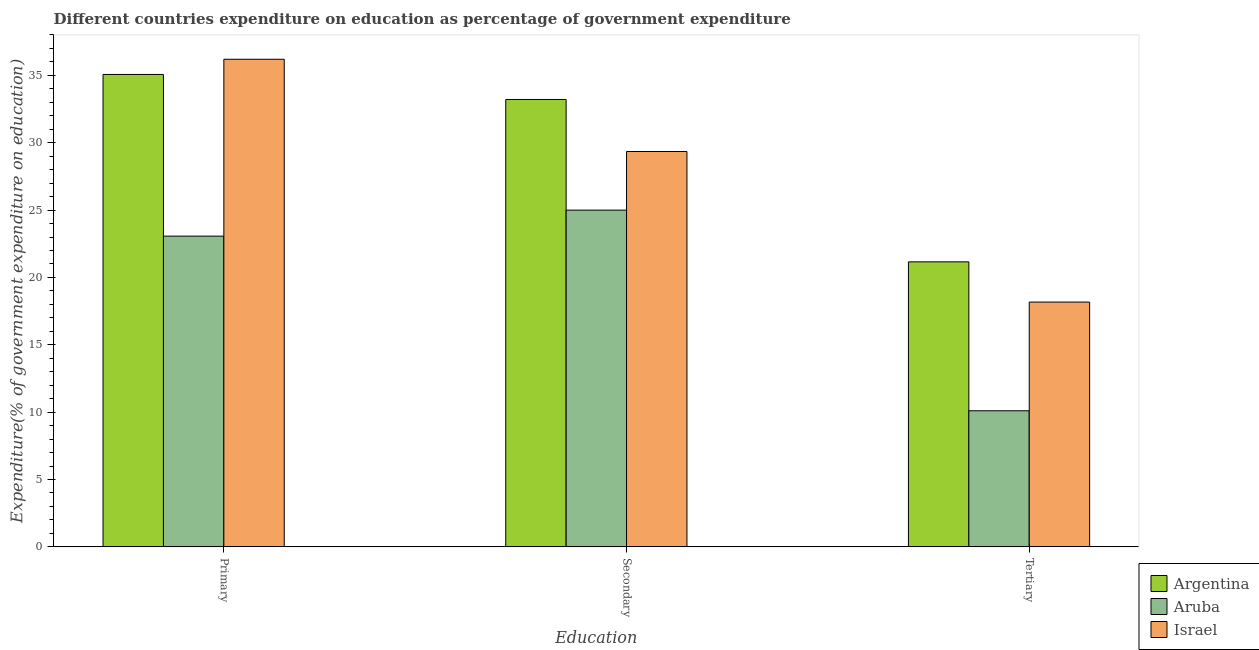How many different coloured bars are there?
Provide a short and direct response. 3. How many bars are there on the 2nd tick from the left?
Your response must be concise. 3. What is the label of the 3rd group of bars from the left?
Your answer should be very brief. Tertiary. What is the expenditure on secondary education in Aruba?
Your response must be concise. 25. Across all countries, what is the maximum expenditure on secondary education?
Your answer should be very brief. 33.21. Across all countries, what is the minimum expenditure on secondary education?
Offer a very short reply. 25. In which country was the expenditure on primary education minimum?
Ensure brevity in your answer.  Aruba. What is the total expenditure on primary education in the graph?
Offer a very short reply. 94.34. What is the difference between the expenditure on primary education in Aruba and that in Argentina?
Ensure brevity in your answer.  -12. What is the difference between the expenditure on tertiary education in Argentina and the expenditure on secondary education in Aruba?
Keep it short and to the point. -3.84. What is the average expenditure on tertiary education per country?
Provide a short and direct response. 16.48. What is the difference between the expenditure on secondary education and expenditure on tertiary education in Israel?
Your answer should be compact. 11.18. What is the ratio of the expenditure on primary education in Argentina to that in Aruba?
Provide a succinct answer. 1.52. What is the difference between the highest and the second highest expenditure on tertiary education?
Keep it short and to the point. 2.99. What is the difference between the highest and the lowest expenditure on tertiary education?
Provide a succinct answer. 11.06. Is the sum of the expenditure on secondary education in Argentina and Israel greater than the maximum expenditure on primary education across all countries?
Your answer should be very brief. Yes. What does the 2nd bar from the left in Primary represents?
Offer a very short reply. Aruba. What does the 3rd bar from the right in Secondary represents?
Your answer should be compact. Argentina. Is it the case that in every country, the sum of the expenditure on primary education and expenditure on secondary education is greater than the expenditure on tertiary education?
Your answer should be compact. Yes. Are the values on the major ticks of Y-axis written in scientific E-notation?
Give a very brief answer. No. Does the graph contain any zero values?
Offer a terse response. No. Where does the legend appear in the graph?
Your answer should be very brief. Bottom right. How are the legend labels stacked?
Offer a very short reply. Vertical. What is the title of the graph?
Provide a short and direct response. Different countries expenditure on education as percentage of government expenditure. What is the label or title of the X-axis?
Provide a short and direct response. Education. What is the label or title of the Y-axis?
Keep it short and to the point. Expenditure(% of government expenditure on education). What is the Expenditure(% of government expenditure on education) in Argentina in Primary?
Give a very brief answer. 35.07. What is the Expenditure(% of government expenditure on education) in Aruba in Primary?
Provide a succinct answer. 23.07. What is the Expenditure(% of government expenditure on education) in Israel in Primary?
Ensure brevity in your answer.  36.2. What is the Expenditure(% of government expenditure on education) in Argentina in Secondary?
Keep it short and to the point. 33.21. What is the Expenditure(% of government expenditure on education) of Aruba in Secondary?
Offer a terse response. 25. What is the Expenditure(% of government expenditure on education) of Israel in Secondary?
Provide a succinct answer. 29.35. What is the Expenditure(% of government expenditure on education) of Argentina in Tertiary?
Offer a terse response. 21.16. What is the Expenditure(% of government expenditure on education) in Aruba in Tertiary?
Your answer should be very brief. 10.1. What is the Expenditure(% of government expenditure on education) in Israel in Tertiary?
Your answer should be compact. 18.17. Across all Education, what is the maximum Expenditure(% of government expenditure on education) of Argentina?
Your answer should be very brief. 35.07. Across all Education, what is the maximum Expenditure(% of government expenditure on education) in Aruba?
Your answer should be compact. 25. Across all Education, what is the maximum Expenditure(% of government expenditure on education) in Israel?
Your answer should be compact. 36.2. Across all Education, what is the minimum Expenditure(% of government expenditure on education) in Argentina?
Ensure brevity in your answer.  21.16. Across all Education, what is the minimum Expenditure(% of government expenditure on education) in Aruba?
Offer a very short reply. 10.1. Across all Education, what is the minimum Expenditure(% of government expenditure on education) of Israel?
Your answer should be compact. 18.17. What is the total Expenditure(% of government expenditure on education) in Argentina in the graph?
Keep it short and to the point. 89.44. What is the total Expenditure(% of government expenditure on education) in Aruba in the graph?
Provide a succinct answer. 58.17. What is the total Expenditure(% of government expenditure on education) in Israel in the graph?
Offer a very short reply. 83.72. What is the difference between the Expenditure(% of government expenditure on education) of Argentina in Primary and that in Secondary?
Offer a very short reply. 1.86. What is the difference between the Expenditure(% of government expenditure on education) in Aruba in Primary and that in Secondary?
Provide a succinct answer. -1.93. What is the difference between the Expenditure(% of government expenditure on education) in Israel in Primary and that in Secondary?
Make the answer very short. 6.85. What is the difference between the Expenditure(% of government expenditure on education) in Argentina in Primary and that in Tertiary?
Provide a succinct answer. 13.91. What is the difference between the Expenditure(% of government expenditure on education) of Aruba in Primary and that in Tertiary?
Your response must be concise. 12.97. What is the difference between the Expenditure(% of government expenditure on education) in Israel in Primary and that in Tertiary?
Ensure brevity in your answer.  18.03. What is the difference between the Expenditure(% of government expenditure on education) of Argentina in Secondary and that in Tertiary?
Provide a succinct answer. 12.05. What is the difference between the Expenditure(% of government expenditure on education) of Aruba in Secondary and that in Tertiary?
Provide a short and direct response. 14.9. What is the difference between the Expenditure(% of government expenditure on education) of Israel in Secondary and that in Tertiary?
Provide a short and direct response. 11.18. What is the difference between the Expenditure(% of government expenditure on education) in Argentina in Primary and the Expenditure(% of government expenditure on education) in Aruba in Secondary?
Offer a terse response. 10.07. What is the difference between the Expenditure(% of government expenditure on education) in Argentina in Primary and the Expenditure(% of government expenditure on education) in Israel in Secondary?
Provide a short and direct response. 5.72. What is the difference between the Expenditure(% of government expenditure on education) in Aruba in Primary and the Expenditure(% of government expenditure on education) in Israel in Secondary?
Make the answer very short. -6.28. What is the difference between the Expenditure(% of government expenditure on education) in Argentina in Primary and the Expenditure(% of government expenditure on education) in Aruba in Tertiary?
Your response must be concise. 24.97. What is the difference between the Expenditure(% of government expenditure on education) of Argentina in Primary and the Expenditure(% of government expenditure on education) of Israel in Tertiary?
Provide a succinct answer. 16.9. What is the difference between the Expenditure(% of government expenditure on education) of Aruba in Primary and the Expenditure(% of government expenditure on education) of Israel in Tertiary?
Provide a succinct answer. 4.89. What is the difference between the Expenditure(% of government expenditure on education) of Argentina in Secondary and the Expenditure(% of government expenditure on education) of Aruba in Tertiary?
Keep it short and to the point. 23.11. What is the difference between the Expenditure(% of government expenditure on education) of Argentina in Secondary and the Expenditure(% of government expenditure on education) of Israel in Tertiary?
Keep it short and to the point. 15.04. What is the difference between the Expenditure(% of government expenditure on education) of Aruba in Secondary and the Expenditure(% of government expenditure on education) of Israel in Tertiary?
Your answer should be compact. 6.83. What is the average Expenditure(% of government expenditure on education) of Argentina per Education?
Offer a very short reply. 29.81. What is the average Expenditure(% of government expenditure on education) in Aruba per Education?
Provide a short and direct response. 19.39. What is the average Expenditure(% of government expenditure on education) in Israel per Education?
Your response must be concise. 27.91. What is the difference between the Expenditure(% of government expenditure on education) of Argentina and Expenditure(% of government expenditure on education) of Aruba in Primary?
Offer a very short reply. 12. What is the difference between the Expenditure(% of government expenditure on education) in Argentina and Expenditure(% of government expenditure on education) in Israel in Primary?
Offer a very short reply. -1.13. What is the difference between the Expenditure(% of government expenditure on education) in Aruba and Expenditure(% of government expenditure on education) in Israel in Primary?
Ensure brevity in your answer.  -13.13. What is the difference between the Expenditure(% of government expenditure on education) in Argentina and Expenditure(% of government expenditure on education) in Aruba in Secondary?
Give a very brief answer. 8.21. What is the difference between the Expenditure(% of government expenditure on education) in Argentina and Expenditure(% of government expenditure on education) in Israel in Secondary?
Your answer should be compact. 3.86. What is the difference between the Expenditure(% of government expenditure on education) in Aruba and Expenditure(% of government expenditure on education) in Israel in Secondary?
Your answer should be very brief. -4.35. What is the difference between the Expenditure(% of government expenditure on education) of Argentina and Expenditure(% of government expenditure on education) of Aruba in Tertiary?
Your answer should be very brief. 11.06. What is the difference between the Expenditure(% of government expenditure on education) in Argentina and Expenditure(% of government expenditure on education) in Israel in Tertiary?
Ensure brevity in your answer.  2.99. What is the difference between the Expenditure(% of government expenditure on education) in Aruba and Expenditure(% of government expenditure on education) in Israel in Tertiary?
Give a very brief answer. -8.07. What is the ratio of the Expenditure(% of government expenditure on education) of Argentina in Primary to that in Secondary?
Provide a succinct answer. 1.06. What is the ratio of the Expenditure(% of government expenditure on education) in Aruba in Primary to that in Secondary?
Keep it short and to the point. 0.92. What is the ratio of the Expenditure(% of government expenditure on education) of Israel in Primary to that in Secondary?
Offer a very short reply. 1.23. What is the ratio of the Expenditure(% of government expenditure on education) of Argentina in Primary to that in Tertiary?
Give a very brief answer. 1.66. What is the ratio of the Expenditure(% of government expenditure on education) in Aruba in Primary to that in Tertiary?
Offer a very short reply. 2.28. What is the ratio of the Expenditure(% of government expenditure on education) of Israel in Primary to that in Tertiary?
Give a very brief answer. 1.99. What is the ratio of the Expenditure(% of government expenditure on education) in Argentina in Secondary to that in Tertiary?
Give a very brief answer. 1.57. What is the ratio of the Expenditure(% of government expenditure on education) in Aruba in Secondary to that in Tertiary?
Keep it short and to the point. 2.47. What is the ratio of the Expenditure(% of government expenditure on education) in Israel in Secondary to that in Tertiary?
Your response must be concise. 1.62. What is the difference between the highest and the second highest Expenditure(% of government expenditure on education) in Argentina?
Provide a succinct answer. 1.86. What is the difference between the highest and the second highest Expenditure(% of government expenditure on education) in Aruba?
Ensure brevity in your answer.  1.93. What is the difference between the highest and the second highest Expenditure(% of government expenditure on education) of Israel?
Make the answer very short. 6.85. What is the difference between the highest and the lowest Expenditure(% of government expenditure on education) of Argentina?
Your response must be concise. 13.91. What is the difference between the highest and the lowest Expenditure(% of government expenditure on education) in Aruba?
Your answer should be very brief. 14.9. What is the difference between the highest and the lowest Expenditure(% of government expenditure on education) of Israel?
Provide a succinct answer. 18.03. 